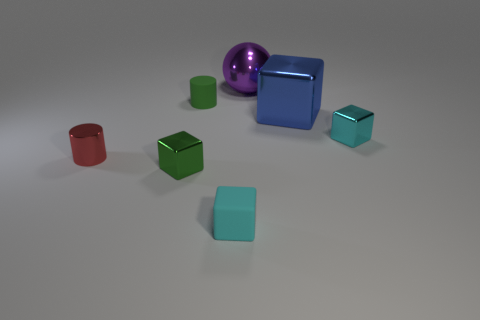What is the material of the green thing that is the same shape as the small red metal object? The green object that shares the same cube shape as the small red object appears to be made of a matte plastic material, characterized by its solid color and lack of reflective properties typically associated with metals. 